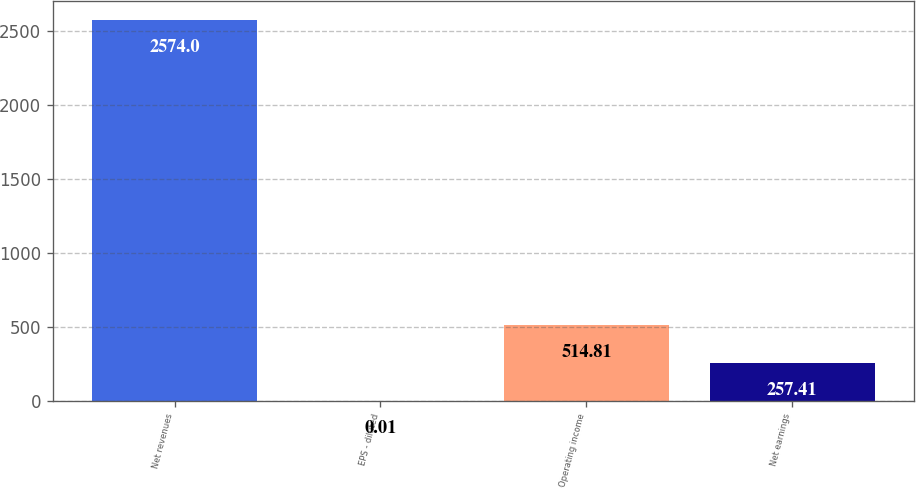Convert chart to OTSL. <chart><loc_0><loc_0><loc_500><loc_500><bar_chart><fcel>Net revenues<fcel>EPS - diluted<fcel>Operating income<fcel>Net earnings<nl><fcel>2574<fcel>0.01<fcel>514.81<fcel>257.41<nl></chart> 